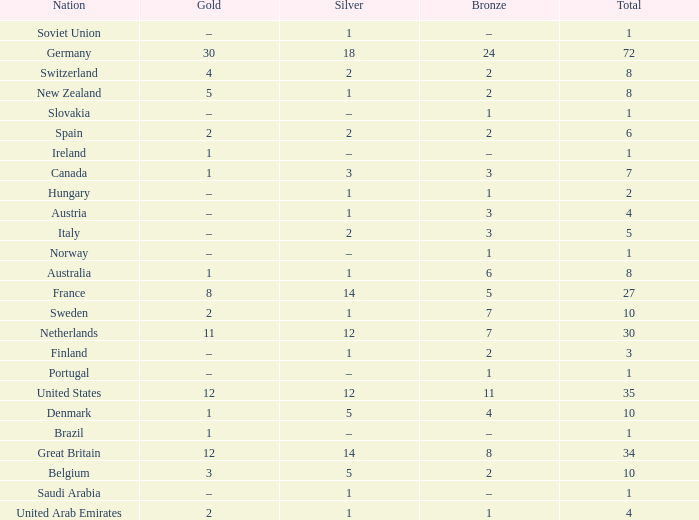What is the total number of Total, when Silver is 1, and when Bronze is 7? 1.0. 